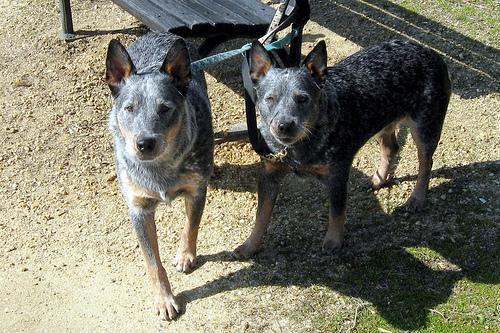How many dogs are in the photo?
Give a very brief answer. 2. How many dogs are there?
Give a very brief answer. 2. How many slices of the pizza have already been eaten?
Give a very brief answer. 0. 